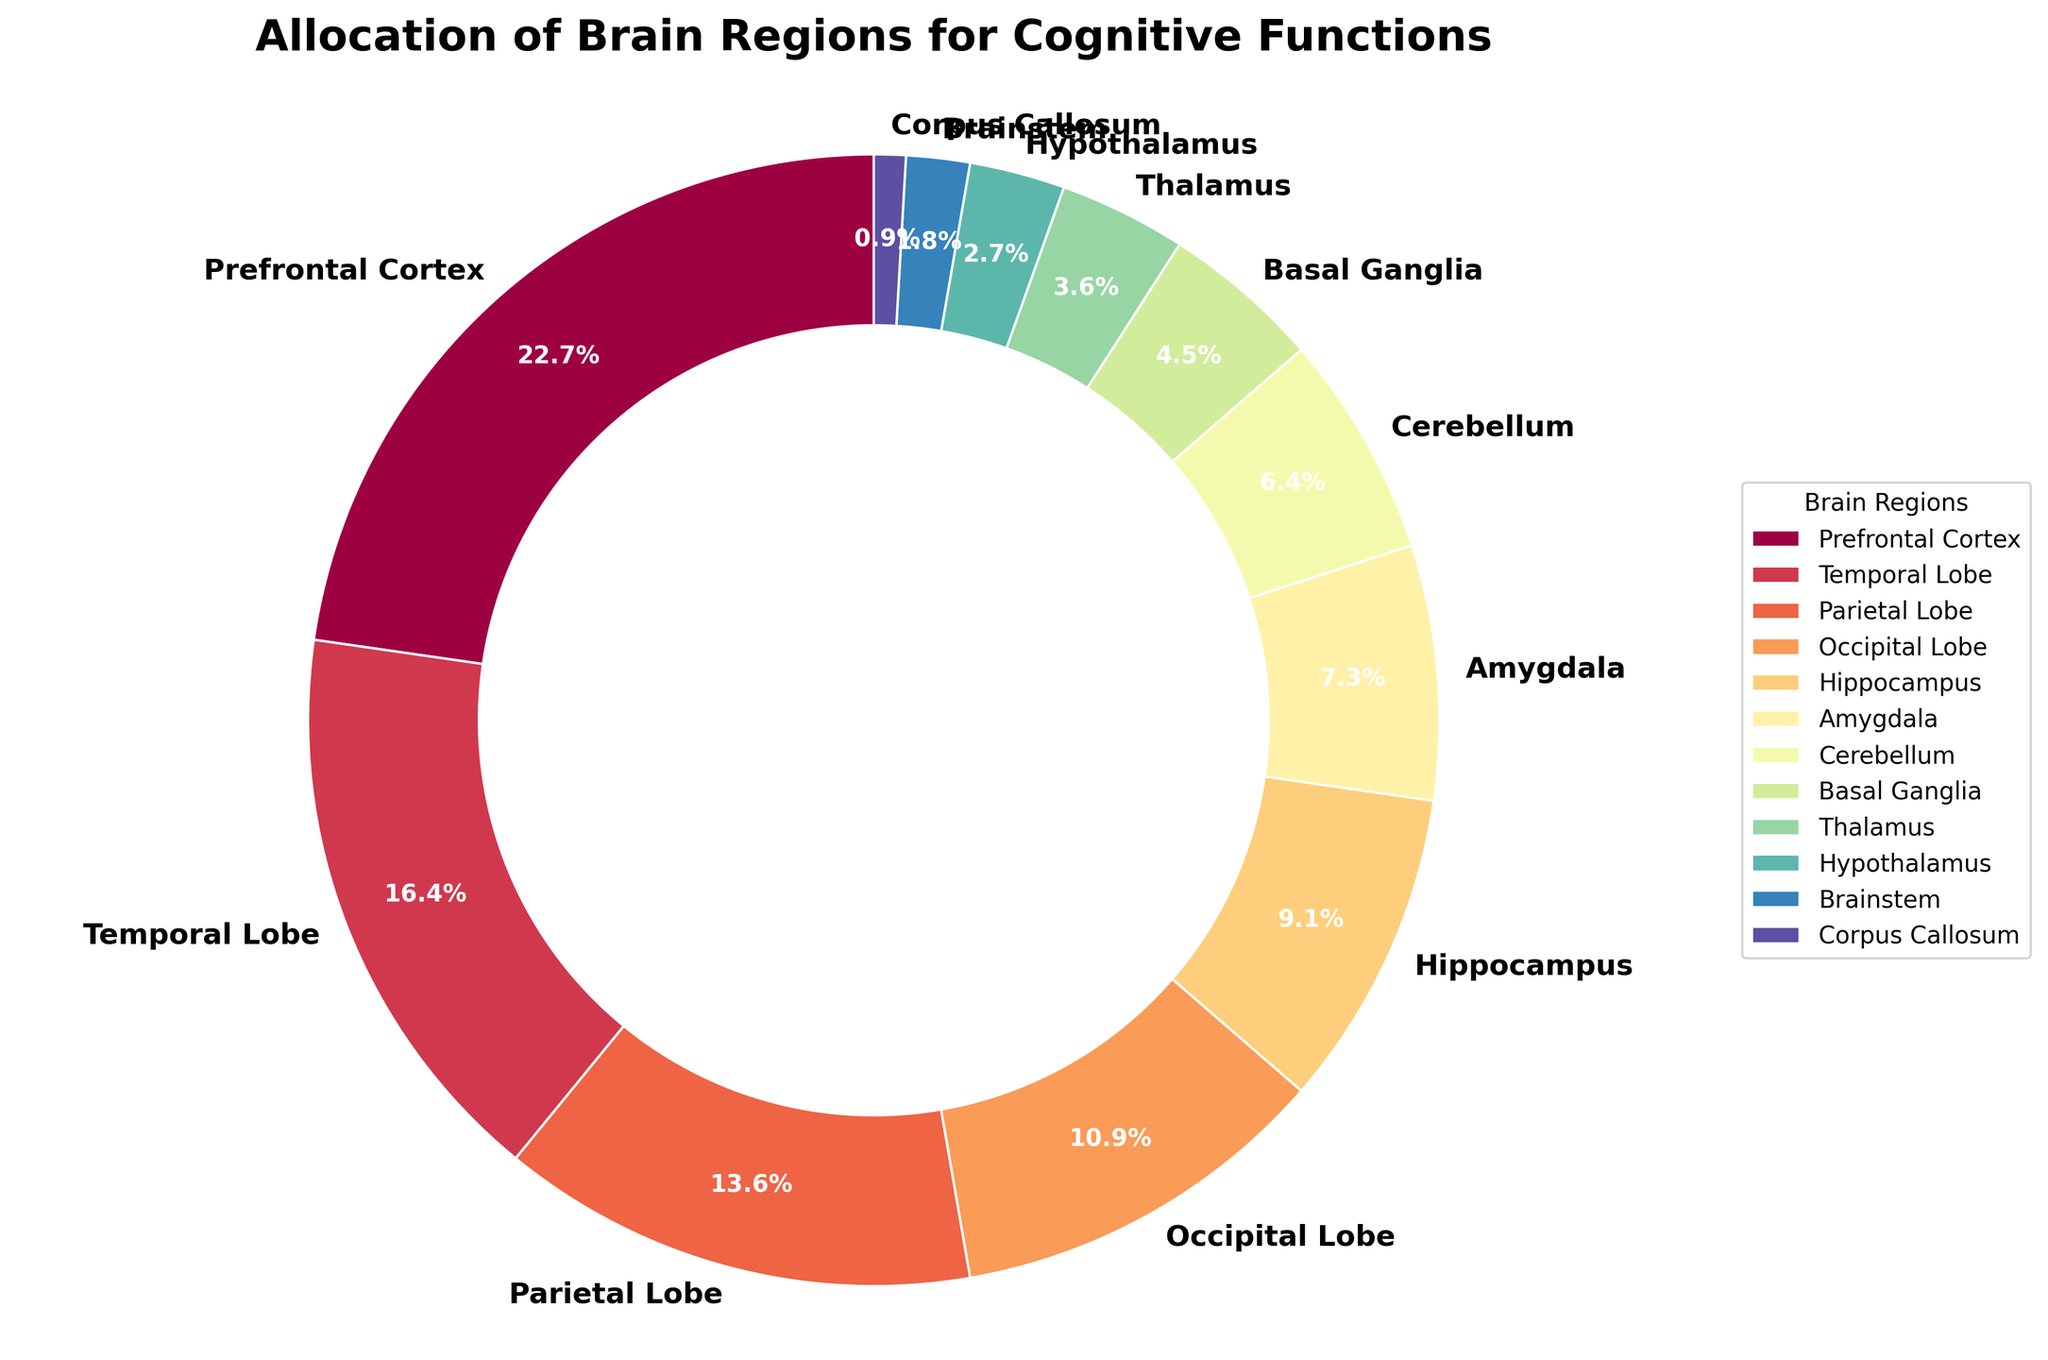What's the largest brain region according to the pie chart? The largest brain region is the Prefrontal Cortex, which occupies the biggest slice in the pie chart. Based on the chart, the size of each section reflects the percentage of allocation.
Answer: Prefrontal Cortex Which region is smaller, the Hypothalamus or the Basal Ganglia? The Basal Ganglia slice is larger than the Hypothalamus slice. Basal Ganglia is at 5%, while Hypothalamus is only 3%. Comparison of the pie slices confirms this.
Answer: Hypothalamus What is the combined percentage of the Occipital Lobe and Temporal Lobe? According to the data, the Occipital Lobe is 12% and the Temporal Lobe is 18%. Adding the two percentages: 12% + 18% = 30%.
Answer: 30% How much larger is the Prefrontal Cortex compared to the Amygdala? The Prefrontal Cortex is 25% and the Amygdala is 8%. The difference in allocation is calculated as 25% - 8% = 17%.
Answer: 17% Rank the brain regions by their percentage allocations from highest to lowest. By examining each section's size, sort them in descending order: Prefrontal Cortex (25%), Temporal Lobe (18%), Parietal Lobe (15%), Occipital Lobe (12%), Hippocampus (10%), Amygdala (8%), Cerebellum (7%), Basal Ganglia (5%), Thalamus (4%), Hypothalamus (3%), Brainstem (2%), Corpus Callosum (1%).
Answer: Prefrontal Cortex, Temporal Lobe, Parietal Lobe, Occipital Lobe, Hippocampus, Amygdala, Cerebellum, Basal Ganglia, Thalamus, Hypothalamus, Brainstem, Corpus Callosum Is the percentage allocation of the Cerebellum closer to that of the Hippocampus or the Basal Ganglia? The Cerebellum's allocation is 7%, Hippocampus is 10%, and Basal Ganglia is 5%. The difference between the Cerebellum and Hippocampus is 3% (10% - 7%), while the difference between the Cerebellum and Basal Ganglia is 2% (7% - 5%). Therefore, the Cerebellum is closer to the Basal Ganglia.
Answer: Basal Ganglia Which two regions combined have the same allocation as the Temporal Lobe? The Temporal Lobe's allocation is 18%. Adding Hippocampus (10%) and Amygdala (8%) gives us 18% (10% + 8%).
Answer: Hippocampus and Amygdala 